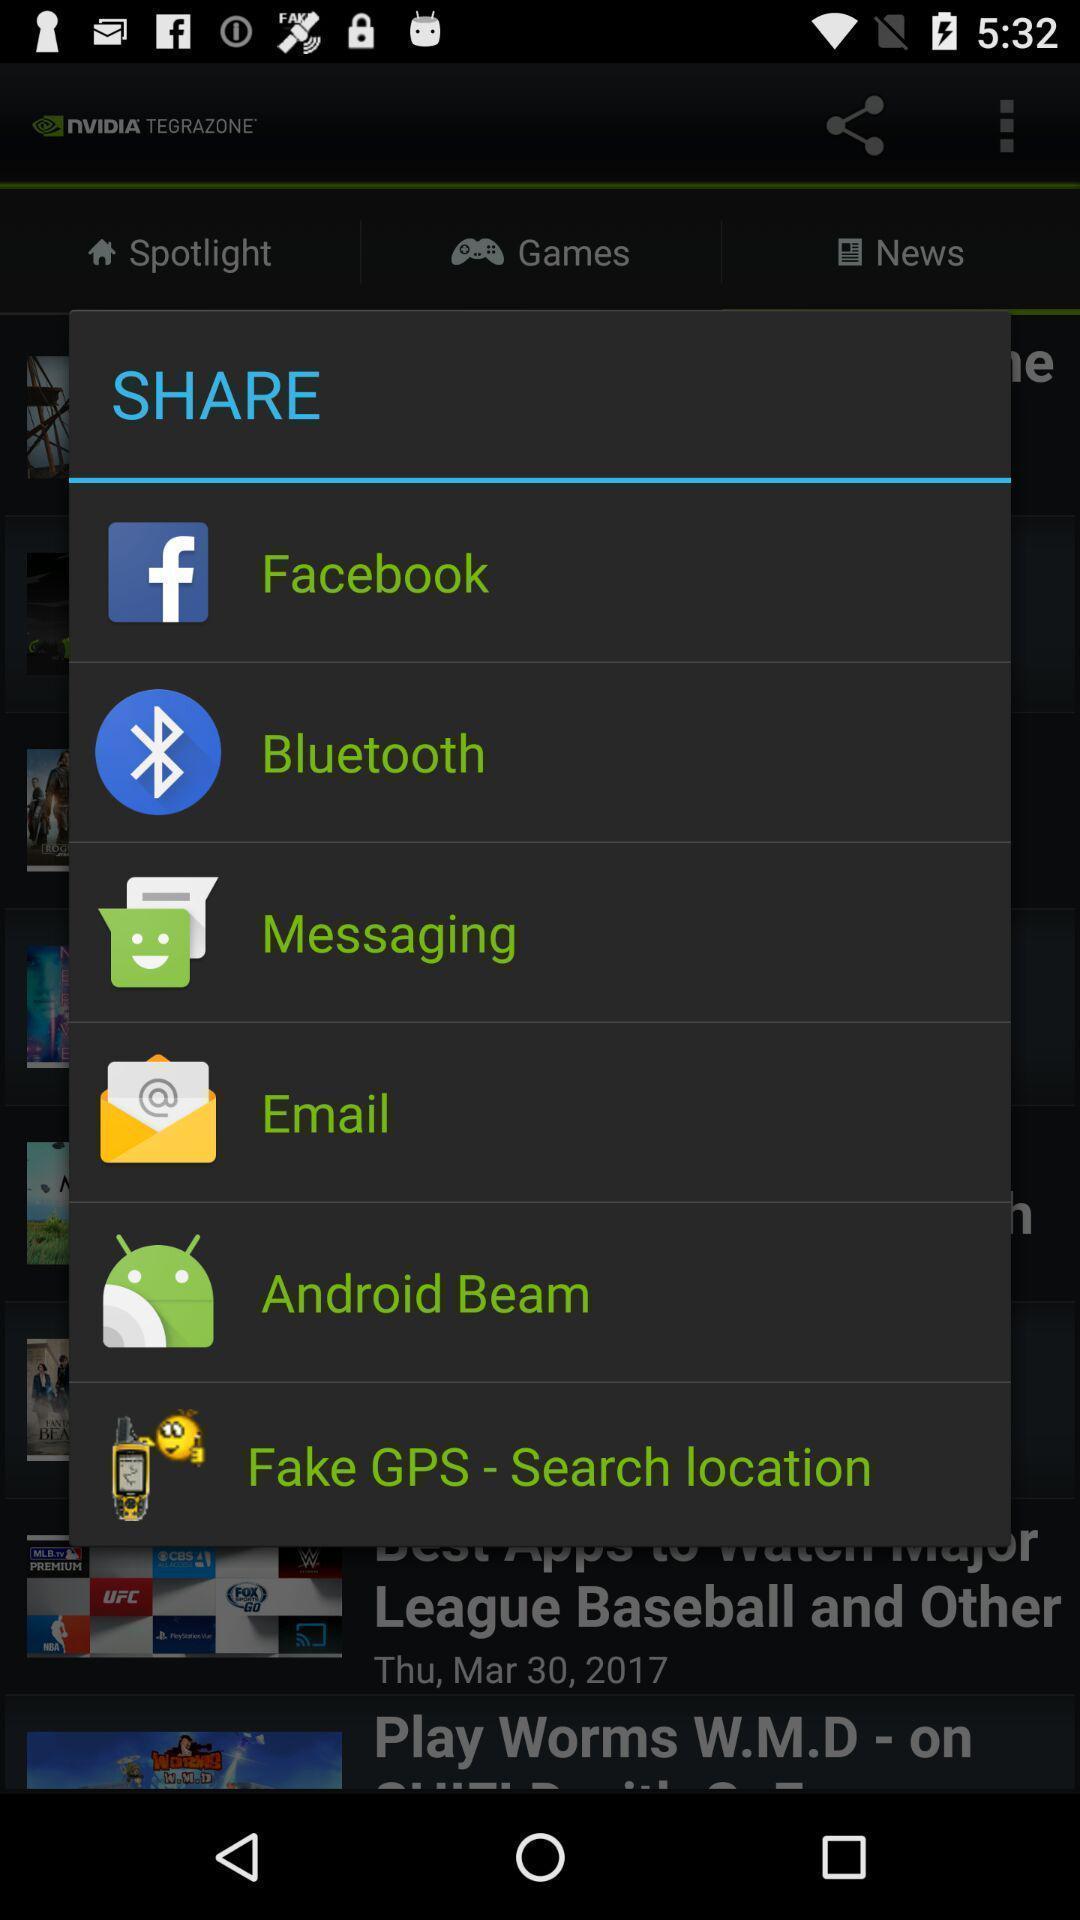Summarize the main components in this picture. Pop-up showing the various app for sharing. 